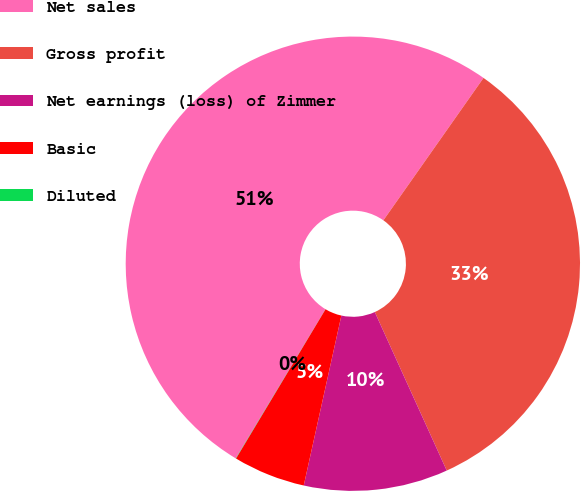<chart> <loc_0><loc_0><loc_500><loc_500><pie_chart><fcel>Net sales<fcel>Gross profit<fcel>Net earnings (loss) of Zimmer<fcel>Basic<fcel>Diluted<nl><fcel>51.13%<fcel>33.46%<fcel>10.25%<fcel>5.13%<fcel>0.02%<nl></chart> 